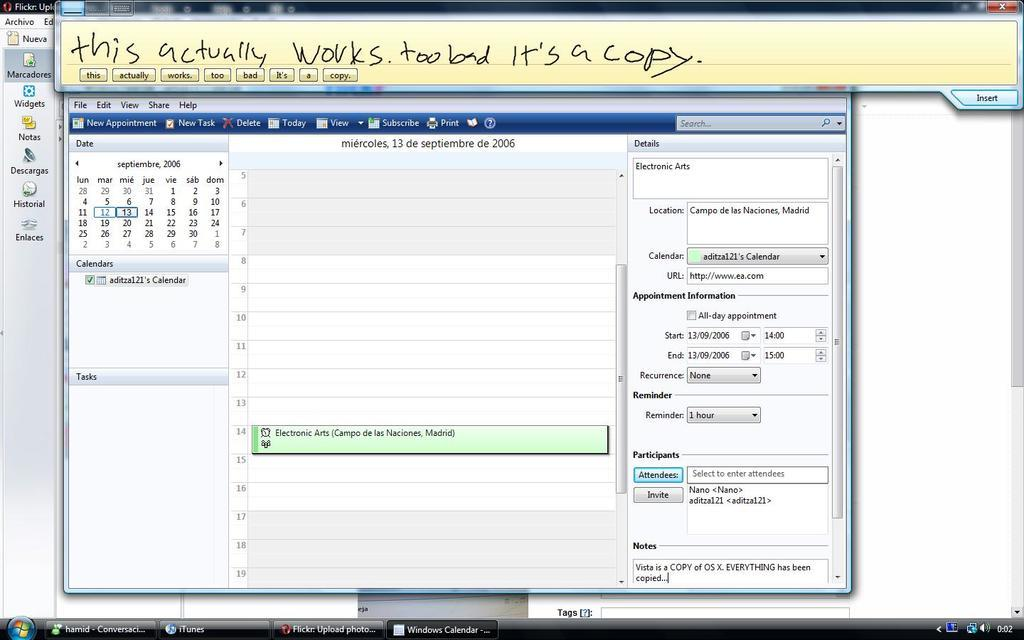<image>
Give a short and clear explanation of the subsequent image. The words This actually works, too bad it's a copy is written on top of a computer screen. 